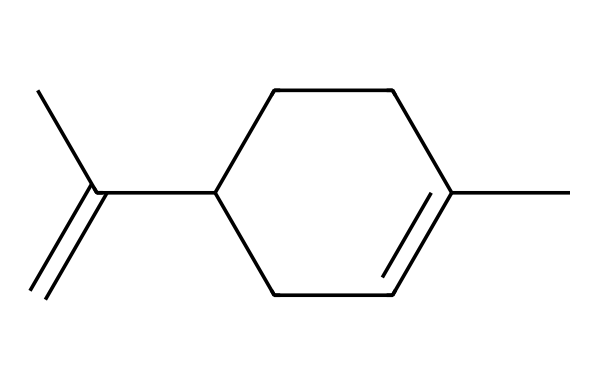What is the total number of carbon atoms in limonene? In the SMILES representation CC1=CCC(CC1)C(=C)C, we can count all the carbon atoms represented by the letters "C". There are a total of 10 carbon atoms visible in the structure.
Answer: 10 How many rings are present in limonene? The "C1" and "C" in the SMILES indicate a cycloalkane, specifically one ring. The presence of the "1" signifies the beginning and end of a ring structure, confirming there is only one cyclic structure.
Answer: 1 What is the degree of saturation for limonene? The degree of saturation can be determined by knowing the total number of hydrogen atoms that would typically bond with the carbon atoms in an alkane minus the number of hydrogens present. For limonene, it has 10 carbon atoms and 16 hydrogen atoms (as deduced from the structure), leading to a degree of saturation of 1 (since there are 2 hydrogens for every carbon in alkanes).
Answer: 1 What type of hydrocarbon is limonene classified as? Given that limonene consists of a ring structure with only single and double bonds, it fits into the cycloalkane category of hydrocarbons, as it possesses a cyclic arrangement.
Answer: cycloalkane How many double bonds does limonene contain? In the SMILES representation, "C(=C)" indicates a double bond. Counting the visible double bonds in the structure confirms that there is one double bond in limonene.
Answer: 1 What is the molecular formula of limonene? By calculating from the structure in the SMILES, we see it has 10 carbons and 16 hydrogens, leading us to determine that the molecular formula is C10H16.
Answer: C10H16 Is limonene a saturated or unsaturated compound? Since limonene has a double bond present in its structure (shown by "C(=C)"), it is categorized as an unsaturated compound due to the presence of this double bond.
Answer: unsaturated 